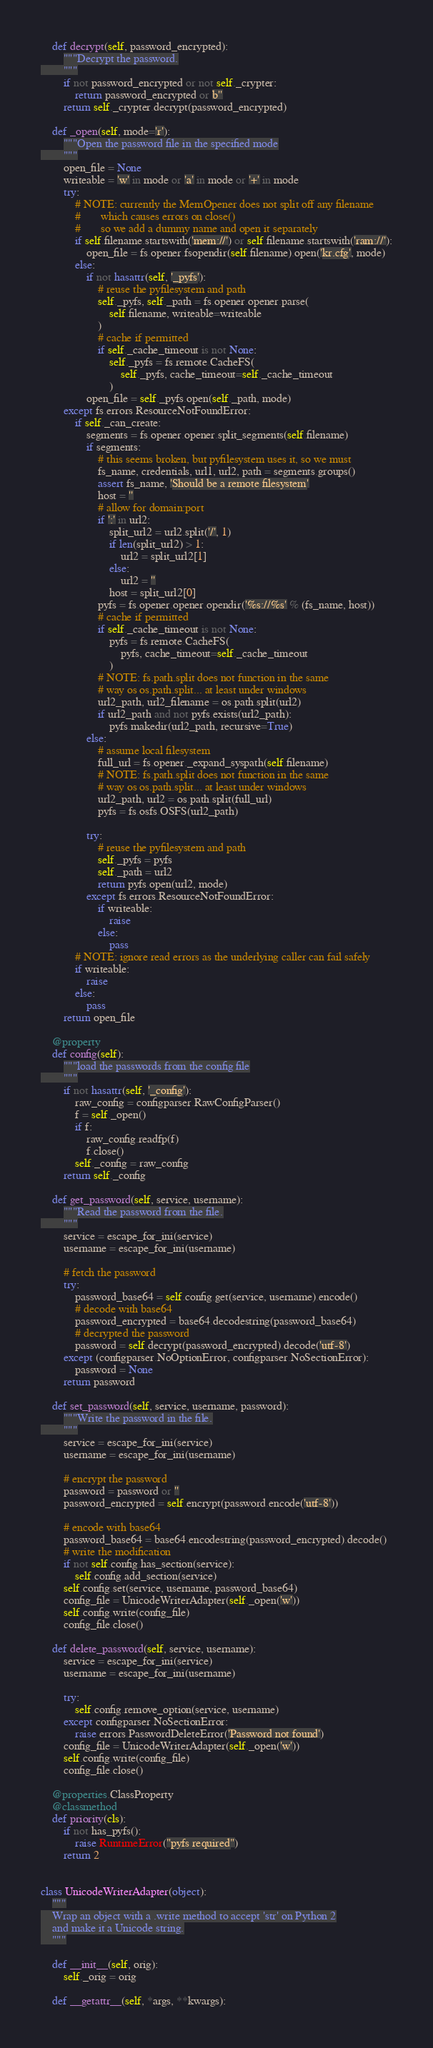Convert code to text. <code><loc_0><loc_0><loc_500><loc_500><_Python_>    def decrypt(self, password_encrypted):
        """Decrypt the password.
        """
        if not password_encrypted or not self._crypter:
            return password_encrypted or b''
        return self._crypter.decrypt(password_encrypted)

    def _open(self, mode='r'):
        """Open the password file in the specified mode
        """
        open_file = None
        writeable = 'w' in mode or 'a' in mode or '+' in mode
        try:
            # NOTE: currently the MemOpener does not split off any filename
            #       which causes errors on close()
            #       so we add a dummy name and open it separately
            if self.filename.startswith('mem://') or self.filename.startswith('ram://'):
                open_file = fs.opener.fsopendir(self.filename).open('kr.cfg', mode)
            else:
                if not hasattr(self, '_pyfs'):
                    # reuse the pyfilesystem and path
                    self._pyfs, self._path = fs.opener.opener.parse(
                        self.filename, writeable=writeable
                    )
                    # cache if permitted
                    if self._cache_timeout is not None:
                        self._pyfs = fs.remote.CacheFS(
                            self._pyfs, cache_timeout=self._cache_timeout
                        )
                open_file = self._pyfs.open(self._path, mode)
        except fs.errors.ResourceNotFoundError:
            if self._can_create:
                segments = fs.opener.opener.split_segments(self.filename)
                if segments:
                    # this seems broken, but pyfilesystem uses it, so we must
                    fs_name, credentials, url1, url2, path = segments.groups()
                    assert fs_name, 'Should be a remote filesystem'
                    host = ''
                    # allow for domain:port
                    if ':' in url2:
                        split_url2 = url2.split('/', 1)
                        if len(split_url2) > 1:
                            url2 = split_url2[1]
                        else:
                            url2 = ''
                        host = split_url2[0]
                    pyfs = fs.opener.opener.opendir('%s://%s' % (fs_name, host))
                    # cache if permitted
                    if self._cache_timeout is not None:
                        pyfs = fs.remote.CacheFS(
                            pyfs, cache_timeout=self._cache_timeout
                        )
                    # NOTE: fs.path.split does not function in the same
                    # way os os.path.split... at least under windows
                    url2_path, url2_filename = os.path.split(url2)
                    if url2_path and not pyfs.exists(url2_path):
                        pyfs.makedir(url2_path, recursive=True)
                else:
                    # assume local filesystem
                    full_url = fs.opener._expand_syspath(self.filename)
                    # NOTE: fs.path.split does not function in the same
                    # way os os.path.split... at least under windows
                    url2_path, url2 = os.path.split(full_url)
                    pyfs = fs.osfs.OSFS(url2_path)

                try:
                    # reuse the pyfilesystem and path
                    self._pyfs = pyfs
                    self._path = url2
                    return pyfs.open(url2, mode)
                except fs.errors.ResourceNotFoundError:
                    if writeable:
                        raise
                    else:
                        pass
            # NOTE: ignore read errors as the underlying caller can fail safely
            if writeable:
                raise
            else:
                pass
        return open_file

    @property
    def config(self):
        """load the passwords from the config file
        """
        if not hasattr(self, '_config'):
            raw_config = configparser.RawConfigParser()
            f = self._open()
            if f:
                raw_config.readfp(f)
                f.close()
            self._config = raw_config
        return self._config

    def get_password(self, service, username):
        """Read the password from the file.
        """
        service = escape_for_ini(service)
        username = escape_for_ini(username)

        # fetch the password
        try:
            password_base64 = self.config.get(service, username).encode()
            # decode with base64
            password_encrypted = base64.decodestring(password_base64)
            # decrypted the password
            password = self.decrypt(password_encrypted).decode('utf-8')
        except (configparser.NoOptionError, configparser.NoSectionError):
            password = None
        return password

    def set_password(self, service, username, password):
        """Write the password in the file.
        """
        service = escape_for_ini(service)
        username = escape_for_ini(username)

        # encrypt the password
        password = password or ''
        password_encrypted = self.encrypt(password.encode('utf-8'))

        # encode with base64
        password_base64 = base64.encodestring(password_encrypted).decode()
        # write the modification
        if not self.config.has_section(service):
            self.config.add_section(service)
        self.config.set(service, username, password_base64)
        config_file = UnicodeWriterAdapter(self._open('w'))
        self.config.write(config_file)
        config_file.close()

    def delete_password(self, service, username):
        service = escape_for_ini(service)
        username = escape_for_ini(username)

        try:
            self.config.remove_option(service, username)
        except configparser.NoSectionError:
            raise errors.PasswordDeleteError('Password not found')
        config_file = UnicodeWriterAdapter(self._open('w'))
        self.config.write(config_file)
        config_file.close()

    @properties.ClassProperty
    @classmethod
    def priority(cls):
        if not has_pyfs():
            raise RuntimeError("pyfs required")
        return 2


class UnicodeWriterAdapter(object):
    """
    Wrap an object with a .write method to accept 'str' on Python 2
    and make it a Unicode string.
    """

    def __init__(self, orig):
        self._orig = orig

    def __getattr__(self, *args, **kwargs):</code> 